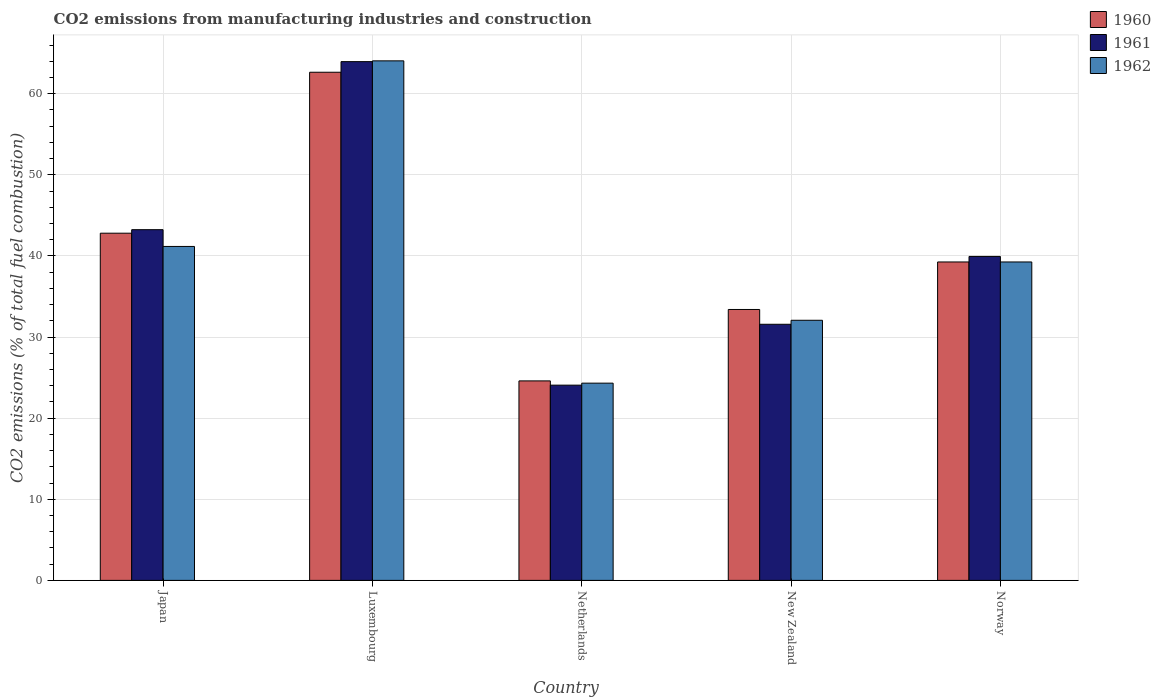How many groups of bars are there?
Provide a short and direct response. 5. Are the number of bars per tick equal to the number of legend labels?
Provide a succinct answer. Yes. How many bars are there on the 5th tick from the left?
Provide a short and direct response. 3. How many bars are there on the 1st tick from the right?
Give a very brief answer. 3. What is the label of the 2nd group of bars from the left?
Offer a terse response. Luxembourg. What is the amount of CO2 emitted in 1962 in Luxembourg?
Make the answer very short. 64.05. Across all countries, what is the maximum amount of CO2 emitted in 1962?
Give a very brief answer. 64.05. Across all countries, what is the minimum amount of CO2 emitted in 1961?
Your response must be concise. 24.07. In which country was the amount of CO2 emitted in 1960 maximum?
Give a very brief answer. Luxembourg. In which country was the amount of CO2 emitted in 1960 minimum?
Keep it short and to the point. Netherlands. What is the total amount of CO2 emitted in 1960 in the graph?
Keep it short and to the point. 202.69. What is the difference between the amount of CO2 emitted in 1960 in Japan and that in Norway?
Keep it short and to the point. 3.55. What is the difference between the amount of CO2 emitted in 1961 in Luxembourg and the amount of CO2 emitted in 1960 in Japan?
Provide a succinct answer. 21.15. What is the average amount of CO2 emitted in 1962 per country?
Keep it short and to the point. 40.17. What is the difference between the amount of CO2 emitted of/in 1961 and amount of CO2 emitted of/in 1962 in Luxembourg?
Offer a very short reply. -0.1. What is the ratio of the amount of CO2 emitted in 1960 in Luxembourg to that in Norway?
Keep it short and to the point. 1.6. Is the difference between the amount of CO2 emitted in 1961 in Netherlands and New Zealand greater than the difference between the amount of CO2 emitted in 1962 in Netherlands and New Zealand?
Provide a succinct answer. Yes. What is the difference between the highest and the second highest amount of CO2 emitted in 1960?
Offer a very short reply. -19.84. What is the difference between the highest and the lowest amount of CO2 emitted in 1960?
Offer a very short reply. 38.05. In how many countries, is the amount of CO2 emitted in 1962 greater than the average amount of CO2 emitted in 1962 taken over all countries?
Give a very brief answer. 2. Is the sum of the amount of CO2 emitted in 1960 in Luxembourg and Netherlands greater than the maximum amount of CO2 emitted in 1962 across all countries?
Provide a short and direct response. Yes. Is it the case that in every country, the sum of the amount of CO2 emitted in 1961 and amount of CO2 emitted in 1960 is greater than the amount of CO2 emitted in 1962?
Your answer should be very brief. Yes. Does the graph contain any zero values?
Offer a very short reply. No. Where does the legend appear in the graph?
Your answer should be compact. Top right. What is the title of the graph?
Make the answer very short. CO2 emissions from manufacturing industries and construction. What is the label or title of the Y-axis?
Make the answer very short. CO2 emissions (% of total fuel combustion). What is the CO2 emissions (% of total fuel combustion) in 1960 in Japan?
Give a very brief answer. 42.8. What is the CO2 emissions (% of total fuel combustion) in 1961 in Japan?
Ensure brevity in your answer.  43.24. What is the CO2 emissions (% of total fuel combustion) of 1962 in Japan?
Your answer should be compact. 41.17. What is the CO2 emissions (% of total fuel combustion) of 1960 in Luxembourg?
Your answer should be very brief. 62.65. What is the CO2 emissions (% of total fuel combustion) in 1961 in Luxembourg?
Your answer should be compact. 63.95. What is the CO2 emissions (% of total fuel combustion) in 1962 in Luxembourg?
Ensure brevity in your answer.  64.05. What is the CO2 emissions (% of total fuel combustion) of 1960 in Netherlands?
Provide a short and direct response. 24.59. What is the CO2 emissions (% of total fuel combustion) in 1961 in Netherlands?
Provide a short and direct response. 24.07. What is the CO2 emissions (% of total fuel combustion) in 1962 in Netherlands?
Your answer should be compact. 24.32. What is the CO2 emissions (% of total fuel combustion) in 1960 in New Zealand?
Your response must be concise. 33.4. What is the CO2 emissions (% of total fuel combustion) in 1961 in New Zealand?
Give a very brief answer. 31.57. What is the CO2 emissions (% of total fuel combustion) in 1962 in New Zealand?
Provide a succinct answer. 32.07. What is the CO2 emissions (% of total fuel combustion) of 1960 in Norway?
Keep it short and to the point. 39.26. What is the CO2 emissions (% of total fuel combustion) in 1961 in Norway?
Your answer should be very brief. 39.94. What is the CO2 emissions (% of total fuel combustion) of 1962 in Norway?
Your response must be concise. 39.26. Across all countries, what is the maximum CO2 emissions (% of total fuel combustion) of 1960?
Make the answer very short. 62.65. Across all countries, what is the maximum CO2 emissions (% of total fuel combustion) of 1961?
Offer a terse response. 63.95. Across all countries, what is the maximum CO2 emissions (% of total fuel combustion) in 1962?
Ensure brevity in your answer.  64.05. Across all countries, what is the minimum CO2 emissions (% of total fuel combustion) of 1960?
Ensure brevity in your answer.  24.59. Across all countries, what is the minimum CO2 emissions (% of total fuel combustion) in 1961?
Provide a succinct answer. 24.07. Across all countries, what is the minimum CO2 emissions (% of total fuel combustion) of 1962?
Your answer should be compact. 24.32. What is the total CO2 emissions (% of total fuel combustion) in 1960 in the graph?
Give a very brief answer. 202.69. What is the total CO2 emissions (% of total fuel combustion) of 1961 in the graph?
Offer a very short reply. 202.77. What is the total CO2 emissions (% of total fuel combustion) in 1962 in the graph?
Provide a succinct answer. 200.86. What is the difference between the CO2 emissions (% of total fuel combustion) in 1960 in Japan and that in Luxembourg?
Ensure brevity in your answer.  -19.84. What is the difference between the CO2 emissions (% of total fuel combustion) in 1961 in Japan and that in Luxembourg?
Give a very brief answer. -20.72. What is the difference between the CO2 emissions (% of total fuel combustion) of 1962 in Japan and that in Luxembourg?
Ensure brevity in your answer.  -22.88. What is the difference between the CO2 emissions (% of total fuel combustion) of 1960 in Japan and that in Netherlands?
Your answer should be compact. 18.21. What is the difference between the CO2 emissions (% of total fuel combustion) of 1961 in Japan and that in Netherlands?
Provide a succinct answer. 19.17. What is the difference between the CO2 emissions (% of total fuel combustion) in 1962 in Japan and that in Netherlands?
Provide a succinct answer. 16.85. What is the difference between the CO2 emissions (% of total fuel combustion) in 1960 in Japan and that in New Zealand?
Offer a very short reply. 9.4. What is the difference between the CO2 emissions (% of total fuel combustion) in 1961 in Japan and that in New Zealand?
Give a very brief answer. 11.66. What is the difference between the CO2 emissions (% of total fuel combustion) of 1962 in Japan and that in New Zealand?
Offer a very short reply. 9.1. What is the difference between the CO2 emissions (% of total fuel combustion) of 1960 in Japan and that in Norway?
Your response must be concise. 3.55. What is the difference between the CO2 emissions (% of total fuel combustion) of 1961 in Japan and that in Norway?
Your answer should be very brief. 3.3. What is the difference between the CO2 emissions (% of total fuel combustion) of 1962 in Japan and that in Norway?
Your answer should be compact. 1.91. What is the difference between the CO2 emissions (% of total fuel combustion) of 1960 in Luxembourg and that in Netherlands?
Make the answer very short. 38.05. What is the difference between the CO2 emissions (% of total fuel combustion) of 1961 in Luxembourg and that in Netherlands?
Provide a short and direct response. 39.88. What is the difference between the CO2 emissions (% of total fuel combustion) of 1962 in Luxembourg and that in Netherlands?
Your answer should be compact. 39.73. What is the difference between the CO2 emissions (% of total fuel combustion) in 1960 in Luxembourg and that in New Zealand?
Your answer should be compact. 29.25. What is the difference between the CO2 emissions (% of total fuel combustion) in 1961 in Luxembourg and that in New Zealand?
Your answer should be very brief. 32.38. What is the difference between the CO2 emissions (% of total fuel combustion) in 1962 in Luxembourg and that in New Zealand?
Make the answer very short. 31.98. What is the difference between the CO2 emissions (% of total fuel combustion) in 1960 in Luxembourg and that in Norway?
Your answer should be compact. 23.39. What is the difference between the CO2 emissions (% of total fuel combustion) of 1961 in Luxembourg and that in Norway?
Your response must be concise. 24.02. What is the difference between the CO2 emissions (% of total fuel combustion) of 1962 in Luxembourg and that in Norway?
Provide a succinct answer. 24.79. What is the difference between the CO2 emissions (% of total fuel combustion) of 1960 in Netherlands and that in New Zealand?
Ensure brevity in your answer.  -8.8. What is the difference between the CO2 emissions (% of total fuel combustion) of 1961 in Netherlands and that in New Zealand?
Make the answer very short. -7.5. What is the difference between the CO2 emissions (% of total fuel combustion) in 1962 in Netherlands and that in New Zealand?
Your response must be concise. -7.75. What is the difference between the CO2 emissions (% of total fuel combustion) of 1960 in Netherlands and that in Norway?
Offer a very short reply. -14.66. What is the difference between the CO2 emissions (% of total fuel combustion) in 1961 in Netherlands and that in Norway?
Your answer should be very brief. -15.87. What is the difference between the CO2 emissions (% of total fuel combustion) in 1962 in Netherlands and that in Norway?
Offer a terse response. -14.94. What is the difference between the CO2 emissions (% of total fuel combustion) in 1960 in New Zealand and that in Norway?
Your answer should be very brief. -5.86. What is the difference between the CO2 emissions (% of total fuel combustion) of 1961 in New Zealand and that in Norway?
Your answer should be very brief. -8.36. What is the difference between the CO2 emissions (% of total fuel combustion) of 1962 in New Zealand and that in Norway?
Ensure brevity in your answer.  -7.19. What is the difference between the CO2 emissions (% of total fuel combustion) of 1960 in Japan and the CO2 emissions (% of total fuel combustion) of 1961 in Luxembourg?
Ensure brevity in your answer.  -21.15. What is the difference between the CO2 emissions (% of total fuel combustion) in 1960 in Japan and the CO2 emissions (% of total fuel combustion) in 1962 in Luxembourg?
Provide a succinct answer. -21.25. What is the difference between the CO2 emissions (% of total fuel combustion) in 1961 in Japan and the CO2 emissions (% of total fuel combustion) in 1962 in Luxembourg?
Provide a short and direct response. -20.81. What is the difference between the CO2 emissions (% of total fuel combustion) of 1960 in Japan and the CO2 emissions (% of total fuel combustion) of 1961 in Netherlands?
Ensure brevity in your answer.  18.73. What is the difference between the CO2 emissions (% of total fuel combustion) of 1960 in Japan and the CO2 emissions (% of total fuel combustion) of 1962 in Netherlands?
Provide a short and direct response. 18.49. What is the difference between the CO2 emissions (% of total fuel combustion) in 1961 in Japan and the CO2 emissions (% of total fuel combustion) in 1962 in Netherlands?
Your answer should be compact. 18.92. What is the difference between the CO2 emissions (% of total fuel combustion) of 1960 in Japan and the CO2 emissions (% of total fuel combustion) of 1961 in New Zealand?
Provide a succinct answer. 11.23. What is the difference between the CO2 emissions (% of total fuel combustion) in 1960 in Japan and the CO2 emissions (% of total fuel combustion) in 1962 in New Zealand?
Your answer should be very brief. 10.73. What is the difference between the CO2 emissions (% of total fuel combustion) of 1961 in Japan and the CO2 emissions (% of total fuel combustion) of 1962 in New Zealand?
Your answer should be very brief. 11.17. What is the difference between the CO2 emissions (% of total fuel combustion) of 1960 in Japan and the CO2 emissions (% of total fuel combustion) of 1961 in Norway?
Your answer should be very brief. 2.86. What is the difference between the CO2 emissions (% of total fuel combustion) of 1960 in Japan and the CO2 emissions (% of total fuel combustion) of 1962 in Norway?
Ensure brevity in your answer.  3.55. What is the difference between the CO2 emissions (% of total fuel combustion) of 1961 in Japan and the CO2 emissions (% of total fuel combustion) of 1962 in Norway?
Make the answer very short. 3.98. What is the difference between the CO2 emissions (% of total fuel combustion) in 1960 in Luxembourg and the CO2 emissions (% of total fuel combustion) in 1961 in Netherlands?
Provide a succinct answer. 38.58. What is the difference between the CO2 emissions (% of total fuel combustion) in 1960 in Luxembourg and the CO2 emissions (% of total fuel combustion) in 1962 in Netherlands?
Your response must be concise. 38.33. What is the difference between the CO2 emissions (% of total fuel combustion) in 1961 in Luxembourg and the CO2 emissions (% of total fuel combustion) in 1962 in Netherlands?
Offer a very short reply. 39.64. What is the difference between the CO2 emissions (% of total fuel combustion) in 1960 in Luxembourg and the CO2 emissions (% of total fuel combustion) in 1961 in New Zealand?
Keep it short and to the point. 31.07. What is the difference between the CO2 emissions (% of total fuel combustion) in 1960 in Luxembourg and the CO2 emissions (% of total fuel combustion) in 1962 in New Zealand?
Provide a succinct answer. 30.58. What is the difference between the CO2 emissions (% of total fuel combustion) in 1961 in Luxembourg and the CO2 emissions (% of total fuel combustion) in 1962 in New Zealand?
Keep it short and to the point. 31.89. What is the difference between the CO2 emissions (% of total fuel combustion) in 1960 in Luxembourg and the CO2 emissions (% of total fuel combustion) in 1961 in Norway?
Your response must be concise. 22.71. What is the difference between the CO2 emissions (% of total fuel combustion) in 1960 in Luxembourg and the CO2 emissions (% of total fuel combustion) in 1962 in Norway?
Provide a short and direct response. 23.39. What is the difference between the CO2 emissions (% of total fuel combustion) in 1961 in Luxembourg and the CO2 emissions (% of total fuel combustion) in 1962 in Norway?
Your answer should be very brief. 24.7. What is the difference between the CO2 emissions (% of total fuel combustion) in 1960 in Netherlands and the CO2 emissions (% of total fuel combustion) in 1961 in New Zealand?
Ensure brevity in your answer.  -6.98. What is the difference between the CO2 emissions (% of total fuel combustion) in 1960 in Netherlands and the CO2 emissions (% of total fuel combustion) in 1962 in New Zealand?
Offer a terse response. -7.47. What is the difference between the CO2 emissions (% of total fuel combustion) of 1961 in Netherlands and the CO2 emissions (% of total fuel combustion) of 1962 in New Zealand?
Make the answer very short. -8. What is the difference between the CO2 emissions (% of total fuel combustion) of 1960 in Netherlands and the CO2 emissions (% of total fuel combustion) of 1961 in Norway?
Make the answer very short. -15.34. What is the difference between the CO2 emissions (% of total fuel combustion) of 1960 in Netherlands and the CO2 emissions (% of total fuel combustion) of 1962 in Norway?
Offer a terse response. -14.66. What is the difference between the CO2 emissions (% of total fuel combustion) of 1961 in Netherlands and the CO2 emissions (% of total fuel combustion) of 1962 in Norway?
Your answer should be very brief. -15.19. What is the difference between the CO2 emissions (% of total fuel combustion) in 1960 in New Zealand and the CO2 emissions (% of total fuel combustion) in 1961 in Norway?
Offer a very short reply. -6.54. What is the difference between the CO2 emissions (% of total fuel combustion) in 1960 in New Zealand and the CO2 emissions (% of total fuel combustion) in 1962 in Norway?
Provide a succinct answer. -5.86. What is the difference between the CO2 emissions (% of total fuel combustion) in 1961 in New Zealand and the CO2 emissions (% of total fuel combustion) in 1962 in Norway?
Your response must be concise. -7.68. What is the average CO2 emissions (% of total fuel combustion) of 1960 per country?
Offer a terse response. 40.54. What is the average CO2 emissions (% of total fuel combustion) in 1961 per country?
Provide a succinct answer. 40.55. What is the average CO2 emissions (% of total fuel combustion) in 1962 per country?
Your answer should be very brief. 40.17. What is the difference between the CO2 emissions (% of total fuel combustion) of 1960 and CO2 emissions (% of total fuel combustion) of 1961 in Japan?
Make the answer very short. -0.44. What is the difference between the CO2 emissions (% of total fuel combustion) of 1960 and CO2 emissions (% of total fuel combustion) of 1962 in Japan?
Offer a terse response. 1.63. What is the difference between the CO2 emissions (% of total fuel combustion) of 1961 and CO2 emissions (% of total fuel combustion) of 1962 in Japan?
Keep it short and to the point. 2.07. What is the difference between the CO2 emissions (% of total fuel combustion) of 1960 and CO2 emissions (% of total fuel combustion) of 1961 in Luxembourg?
Offer a very short reply. -1.31. What is the difference between the CO2 emissions (% of total fuel combustion) in 1960 and CO2 emissions (% of total fuel combustion) in 1962 in Luxembourg?
Ensure brevity in your answer.  -1.4. What is the difference between the CO2 emissions (% of total fuel combustion) in 1961 and CO2 emissions (% of total fuel combustion) in 1962 in Luxembourg?
Your answer should be compact. -0.1. What is the difference between the CO2 emissions (% of total fuel combustion) of 1960 and CO2 emissions (% of total fuel combustion) of 1961 in Netherlands?
Ensure brevity in your answer.  0.52. What is the difference between the CO2 emissions (% of total fuel combustion) in 1960 and CO2 emissions (% of total fuel combustion) in 1962 in Netherlands?
Offer a terse response. 0.28. What is the difference between the CO2 emissions (% of total fuel combustion) of 1961 and CO2 emissions (% of total fuel combustion) of 1962 in Netherlands?
Your answer should be very brief. -0.25. What is the difference between the CO2 emissions (% of total fuel combustion) in 1960 and CO2 emissions (% of total fuel combustion) in 1961 in New Zealand?
Give a very brief answer. 1.82. What is the difference between the CO2 emissions (% of total fuel combustion) in 1960 and CO2 emissions (% of total fuel combustion) in 1962 in New Zealand?
Provide a succinct answer. 1.33. What is the difference between the CO2 emissions (% of total fuel combustion) of 1961 and CO2 emissions (% of total fuel combustion) of 1962 in New Zealand?
Offer a terse response. -0.49. What is the difference between the CO2 emissions (% of total fuel combustion) in 1960 and CO2 emissions (% of total fuel combustion) in 1961 in Norway?
Ensure brevity in your answer.  -0.68. What is the difference between the CO2 emissions (% of total fuel combustion) of 1960 and CO2 emissions (% of total fuel combustion) of 1962 in Norway?
Offer a very short reply. 0. What is the difference between the CO2 emissions (% of total fuel combustion) in 1961 and CO2 emissions (% of total fuel combustion) in 1962 in Norway?
Make the answer very short. 0.68. What is the ratio of the CO2 emissions (% of total fuel combustion) of 1960 in Japan to that in Luxembourg?
Keep it short and to the point. 0.68. What is the ratio of the CO2 emissions (% of total fuel combustion) in 1961 in Japan to that in Luxembourg?
Offer a terse response. 0.68. What is the ratio of the CO2 emissions (% of total fuel combustion) in 1962 in Japan to that in Luxembourg?
Your response must be concise. 0.64. What is the ratio of the CO2 emissions (% of total fuel combustion) in 1960 in Japan to that in Netherlands?
Your response must be concise. 1.74. What is the ratio of the CO2 emissions (% of total fuel combustion) in 1961 in Japan to that in Netherlands?
Offer a very short reply. 1.8. What is the ratio of the CO2 emissions (% of total fuel combustion) of 1962 in Japan to that in Netherlands?
Provide a succinct answer. 1.69. What is the ratio of the CO2 emissions (% of total fuel combustion) of 1960 in Japan to that in New Zealand?
Ensure brevity in your answer.  1.28. What is the ratio of the CO2 emissions (% of total fuel combustion) of 1961 in Japan to that in New Zealand?
Provide a short and direct response. 1.37. What is the ratio of the CO2 emissions (% of total fuel combustion) of 1962 in Japan to that in New Zealand?
Keep it short and to the point. 1.28. What is the ratio of the CO2 emissions (% of total fuel combustion) in 1960 in Japan to that in Norway?
Provide a short and direct response. 1.09. What is the ratio of the CO2 emissions (% of total fuel combustion) in 1961 in Japan to that in Norway?
Provide a succinct answer. 1.08. What is the ratio of the CO2 emissions (% of total fuel combustion) in 1962 in Japan to that in Norway?
Ensure brevity in your answer.  1.05. What is the ratio of the CO2 emissions (% of total fuel combustion) of 1960 in Luxembourg to that in Netherlands?
Your answer should be very brief. 2.55. What is the ratio of the CO2 emissions (% of total fuel combustion) in 1961 in Luxembourg to that in Netherlands?
Make the answer very short. 2.66. What is the ratio of the CO2 emissions (% of total fuel combustion) in 1962 in Luxembourg to that in Netherlands?
Offer a terse response. 2.63. What is the ratio of the CO2 emissions (% of total fuel combustion) in 1960 in Luxembourg to that in New Zealand?
Keep it short and to the point. 1.88. What is the ratio of the CO2 emissions (% of total fuel combustion) of 1961 in Luxembourg to that in New Zealand?
Provide a short and direct response. 2.03. What is the ratio of the CO2 emissions (% of total fuel combustion) in 1962 in Luxembourg to that in New Zealand?
Offer a terse response. 2. What is the ratio of the CO2 emissions (% of total fuel combustion) of 1960 in Luxembourg to that in Norway?
Offer a terse response. 1.6. What is the ratio of the CO2 emissions (% of total fuel combustion) of 1961 in Luxembourg to that in Norway?
Offer a very short reply. 1.6. What is the ratio of the CO2 emissions (% of total fuel combustion) of 1962 in Luxembourg to that in Norway?
Provide a succinct answer. 1.63. What is the ratio of the CO2 emissions (% of total fuel combustion) of 1960 in Netherlands to that in New Zealand?
Provide a succinct answer. 0.74. What is the ratio of the CO2 emissions (% of total fuel combustion) in 1961 in Netherlands to that in New Zealand?
Keep it short and to the point. 0.76. What is the ratio of the CO2 emissions (% of total fuel combustion) in 1962 in Netherlands to that in New Zealand?
Provide a short and direct response. 0.76. What is the ratio of the CO2 emissions (% of total fuel combustion) in 1960 in Netherlands to that in Norway?
Your answer should be very brief. 0.63. What is the ratio of the CO2 emissions (% of total fuel combustion) in 1961 in Netherlands to that in Norway?
Your answer should be compact. 0.6. What is the ratio of the CO2 emissions (% of total fuel combustion) in 1962 in Netherlands to that in Norway?
Provide a succinct answer. 0.62. What is the ratio of the CO2 emissions (% of total fuel combustion) in 1960 in New Zealand to that in Norway?
Make the answer very short. 0.85. What is the ratio of the CO2 emissions (% of total fuel combustion) of 1961 in New Zealand to that in Norway?
Keep it short and to the point. 0.79. What is the ratio of the CO2 emissions (% of total fuel combustion) in 1962 in New Zealand to that in Norway?
Offer a very short reply. 0.82. What is the difference between the highest and the second highest CO2 emissions (% of total fuel combustion) of 1960?
Offer a terse response. 19.84. What is the difference between the highest and the second highest CO2 emissions (% of total fuel combustion) of 1961?
Provide a succinct answer. 20.72. What is the difference between the highest and the second highest CO2 emissions (% of total fuel combustion) in 1962?
Offer a very short reply. 22.88. What is the difference between the highest and the lowest CO2 emissions (% of total fuel combustion) in 1960?
Offer a terse response. 38.05. What is the difference between the highest and the lowest CO2 emissions (% of total fuel combustion) of 1961?
Offer a very short reply. 39.88. What is the difference between the highest and the lowest CO2 emissions (% of total fuel combustion) in 1962?
Your response must be concise. 39.73. 